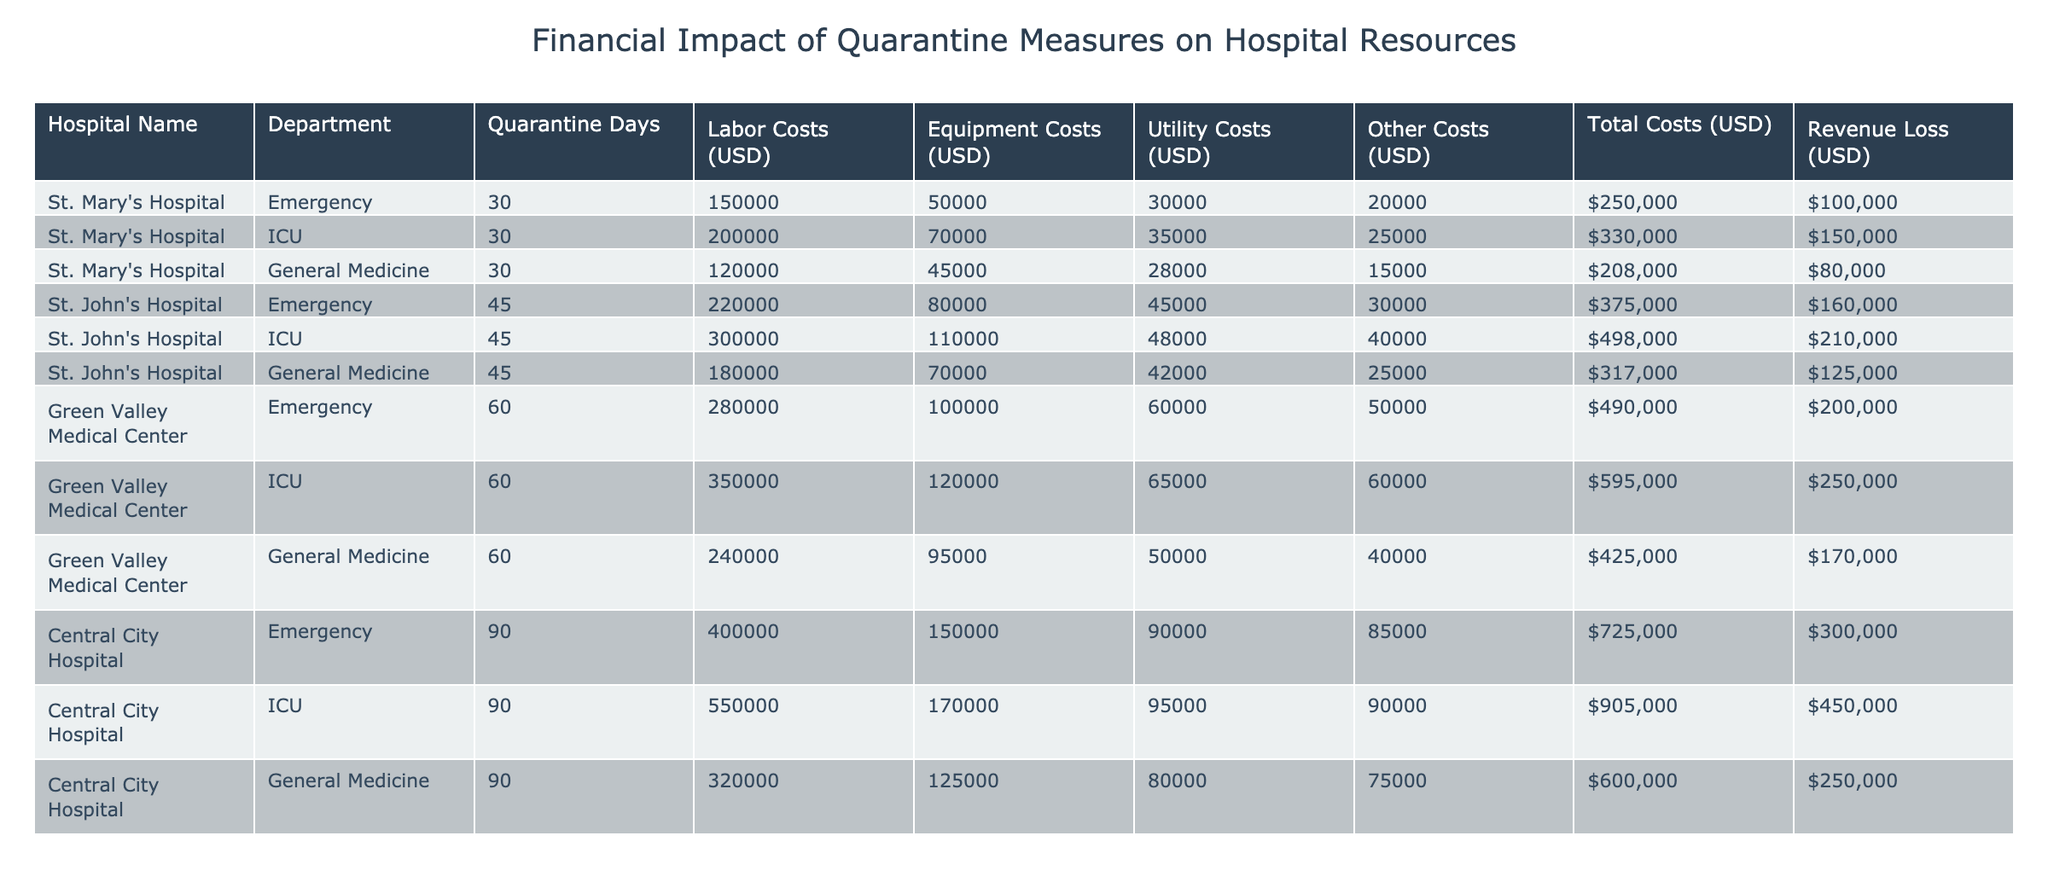What is the total cost for St. John's Hospital's ICU department? The value for the total cost of St. John's Hospital's ICU department is directly listed in the table as 498,000 USD.
Answer: 498,000 USD What department at Green Valley Medical Center has the highest total costs? The total costs for each department at Green Valley Medical Center are Emergency (490,000 USD), ICU (595,000 USD), and General Medicine (425,000 USD). The ICU has the highest total cost at 595,000 USD.
Answer: ICU How much revenue loss did Central City Hospital incur in total across all departments? The revenue loss for each department at Central City Hospital is 300,000 USD for Emergency, 450,000 USD for ICU, and 250,000 USD for General Medicine. Adding these amounts gives 300,000 + 450,000 + 250,000 = 1,000,000 USD for total revenue loss.
Answer: 1,000,000 USD Did St. Mary's Hospital's revenue loss exceed its total costs? St. Mary's Hospital's total costs are 250,000 USD, and its revenue loss is 100,000 USD. Since 100,000 is less than 250,000, the statement is false.
Answer: No What is the average total cost per department for Green Valley Medical Center? The total costs are 490,000 USD for Emergency, 595,000 USD for ICU, and 425,000 USD for General Medicine. Adding these yields a total of 490,000 + 595,000 + 425,000 = 1,510,000 USD. Dividing by 3 (the number of departments), the average total cost is 1,510,000 / 3 = 503,333.33 USD.
Answer: 503,333.33 USD Which hospital experienced the longest quarantine days and what was the corresponding revenue loss? The hospital with the longest quarantine days is Central City Hospital with 90 days, and the revenue loss for its departments sums to 1,000,000 USD (300,000 + 450,000 + 250,000).
Answer: Central City Hospital, 1,000,000 USD What is the difference in total costs between the Emergency department at St. John's Hospital and the Emergency department at St. Mary's Hospital? The total cost for the Emergency department at St. John's Hospital is 375,000 USD, while for St. Mary's Hospital, it is 250,000 USD. The difference is calculated as 375,000 - 250,000 = 125,000 USD.
Answer: 125,000 USD Which department has the lowest utility costs at St. Mary's Hospital? The utility costs for St. Mary's Hospital are 30,000 USD for Emergency, 35,000 USD for ICU, and 28,000 USD for General Medicine. The lowest is 28,000 USD for General Medicine.
Answer: General Medicine 